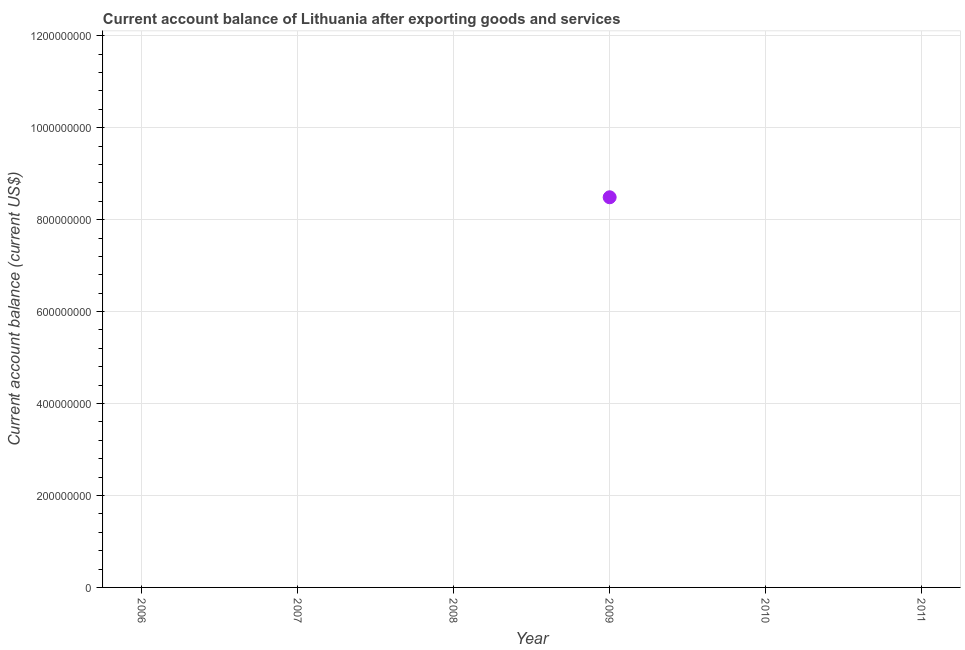Across all years, what is the maximum current account balance?
Your answer should be compact. 8.49e+08. In which year was the current account balance maximum?
Offer a terse response. 2009. What is the sum of the current account balance?
Offer a terse response. 8.49e+08. What is the average current account balance per year?
Your answer should be compact. 1.41e+08. What is the median current account balance?
Offer a very short reply. 0. What is the difference between the highest and the lowest current account balance?
Offer a terse response. 8.49e+08. How many years are there in the graph?
Offer a very short reply. 6. Does the graph contain any zero values?
Provide a succinct answer. Yes. What is the title of the graph?
Your answer should be very brief. Current account balance of Lithuania after exporting goods and services. What is the label or title of the Y-axis?
Keep it short and to the point. Current account balance (current US$). What is the Current account balance (current US$) in 2007?
Provide a short and direct response. 0. What is the Current account balance (current US$) in 2009?
Your answer should be compact. 8.49e+08. 